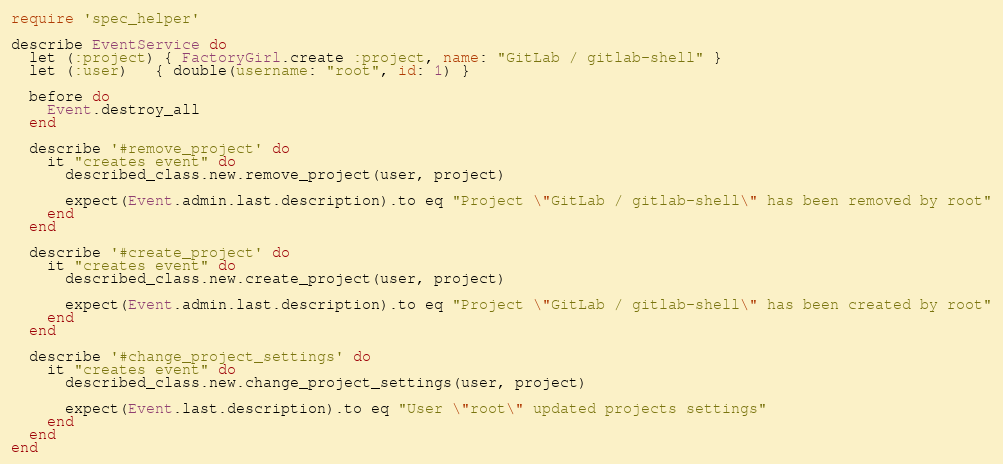<code> <loc_0><loc_0><loc_500><loc_500><_Ruby_>require 'spec_helper'

describe EventService do
  let (:project) { FactoryGirl.create :project, name: "GitLab / gitlab-shell" }
  let (:user)   { double(username: "root", id: 1) }

  before do
    Event.destroy_all
  end
  
  describe '#remove_project' do
    it "creates event" do
      described_class.new.remove_project(user, project)

      expect(Event.admin.last.description).to eq "Project \"GitLab / gitlab-shell\" has been removed by root"
    end
  end

  describe '#create_project' do
    it "creates event" do
      described_class.new.create_project(user, project)

      expect(Event.admin.last.description).to eq "Project \"GitLab / gitlab-shell\" has been created by root"
    end
  end

  describe '#change_project_settings' do
    it "creates event" do
      described_class.new.change_project_settings(user, project)

      expect(Event.last.description).to eq "User \"root\" updated projects settings"
    end
  end
end
</code> 